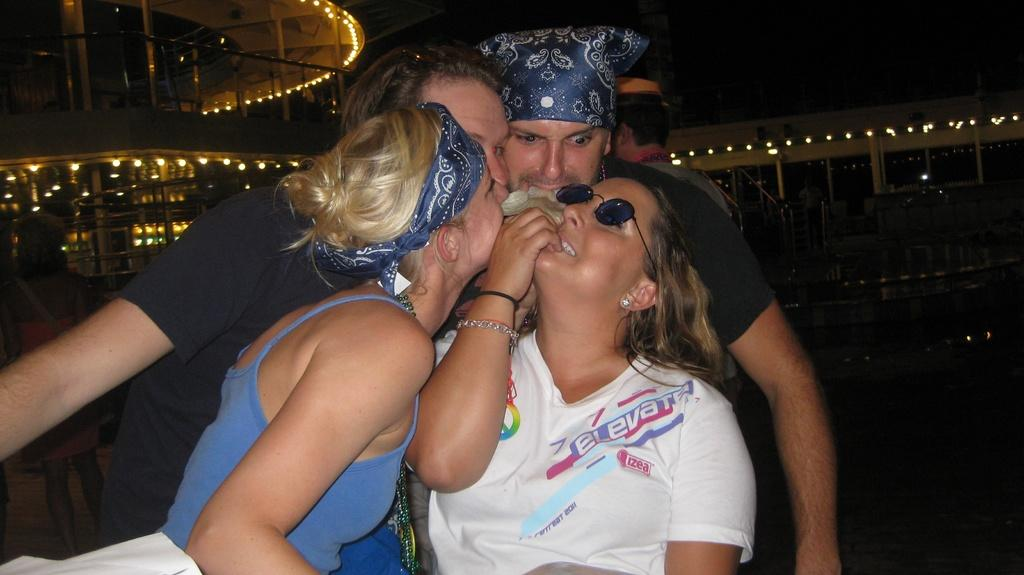How many people are in the main group in the image? There are four persons in the middle of the image. What can be seen in the background of the image? There is a building, lights, and a staircase in the background of the image. Are there any other people visible in the image besides the main group? Yes, there are additional persons in the background of the image. What type of cable is being used by the creator in the image? There is no creator or cable present in the image. How many visitors are visible in the image? The term "visitor" is not mentioned in the facts provided, and therefore it cannot be determined from the image. 